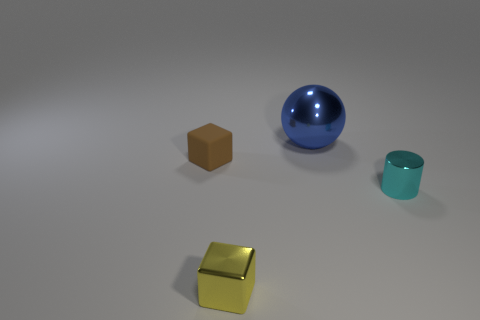Subtract all purple spheres. Subtract all red cubes. How many spheres are left? 1 Add 3 cyan things. How many objects exist? 7 Subtract all spheres. How many objects are left? 3 Add 3 rubber objects. How many rubber objects exist? 4 Subtract 0 gray spheres. How many objects are left? 4 Subtract all yellow rubber objects. Subtract all rubber objects. How many objects are left? 3 Add 3 tiny yellow metallic blocks. How many tiny yellow metallic blocks are left? 4 